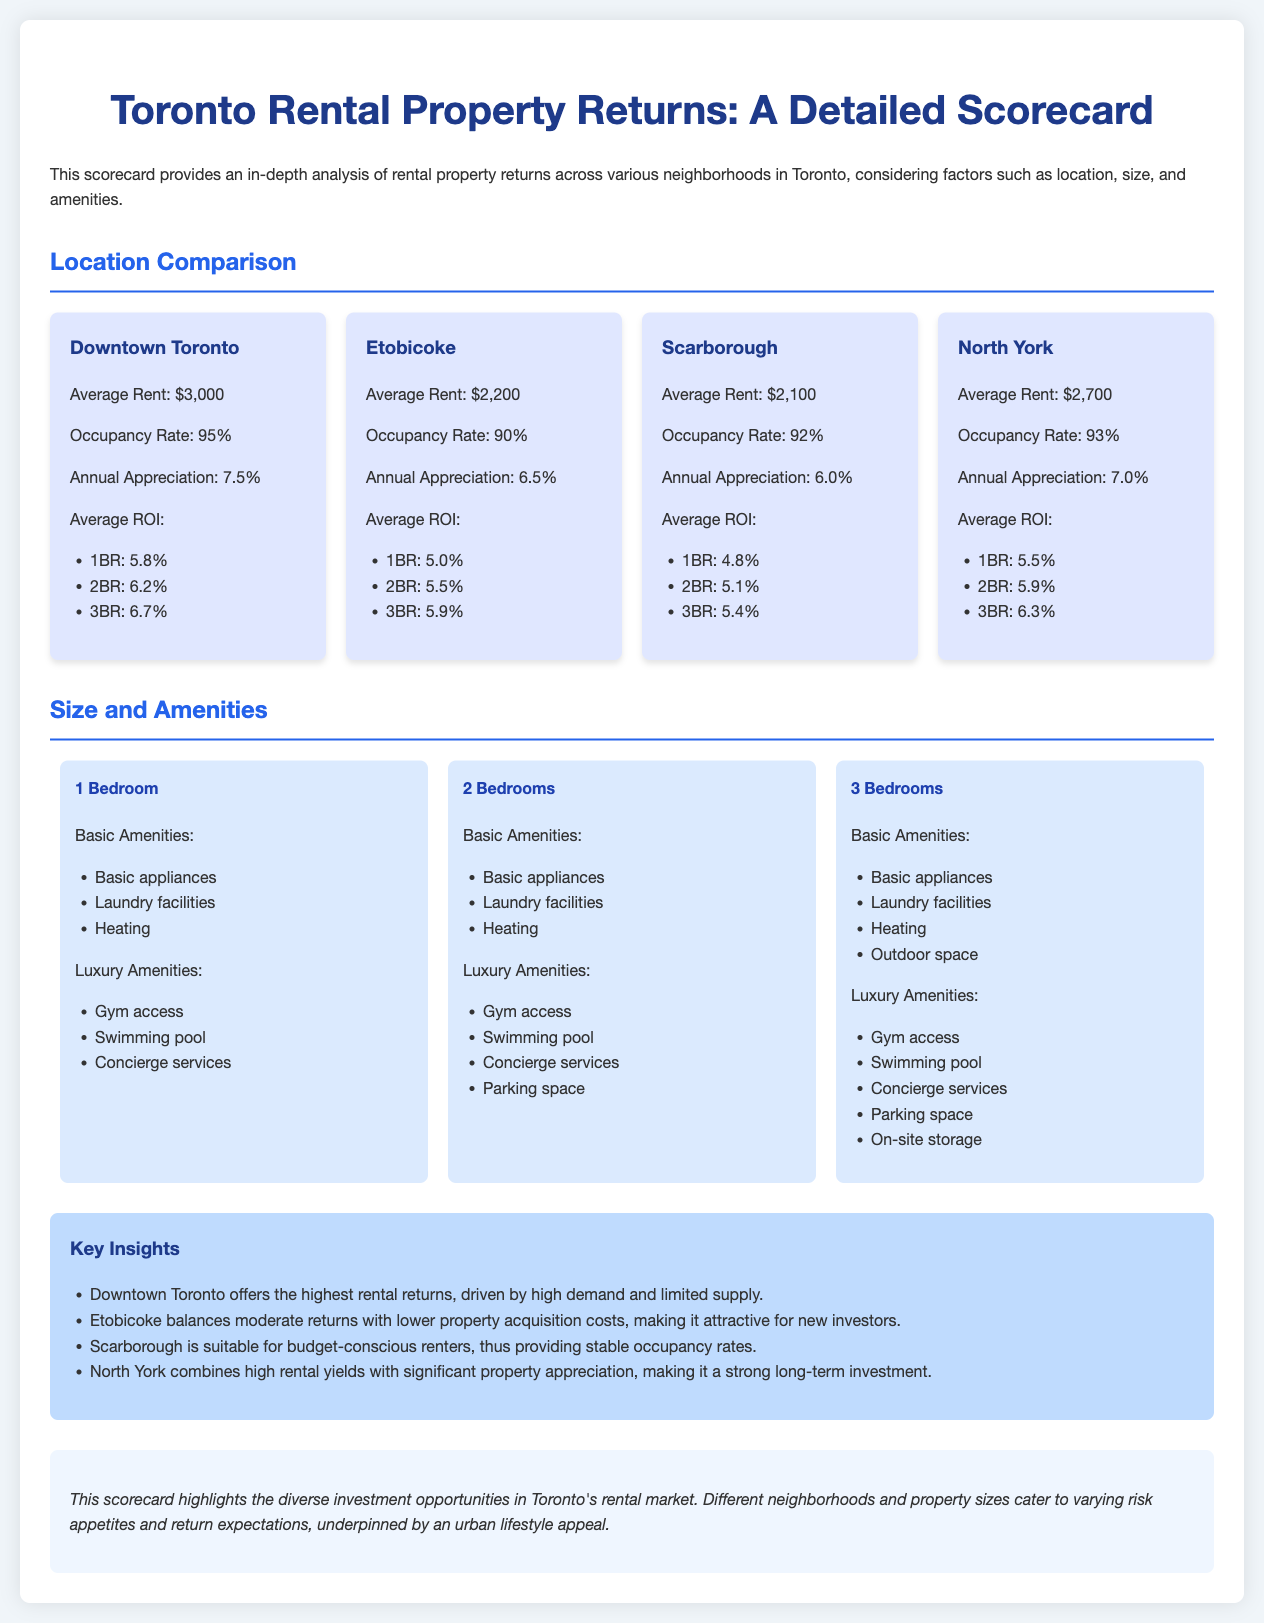what is the average rent in Downtown Toronto? The average rent is specifically mentioned in the document for Downtown Toronto as $3,000.
Answer: $3,000 what is the occupancy rate for Etobicoke? The document states that the occupancy rate for Etobicoke is 90%.
Answer: 90% which neighborhood has the highest annual appreciation? According to the document, Downtown Toronto has the highest annual appreciation at 7.5%.
Answer: 7.5% what is the average ROI for a 2-bedroom in North York? The average ROI for a 2-bedroom in North York is mentioned in the document as 5.9%.
Answer: 5.9% which area is described as suitable for budget-conscious renters? The document describes Scarborough as suitable for budget-conscious renters.
Answer: Scarborough what amenities are included for a 3-bedroom unit? The basic and luxury amenities listed for a 3-bedroom include basic appliances, laundry facilities, heating, outdoor space, gym access, swimming pool, concierge services, parking space, and on-site storage.
Answer: See document for full list what key insight highlights North York? The document notes that North York combines high rental yields with significant property appreciation.
Answer: High rental yields and appreciation how many luxury amenities are listed for a 2-bedroom unit? The document lists four luxury amenities for a 2-bedroom unit.
Answer: Four 